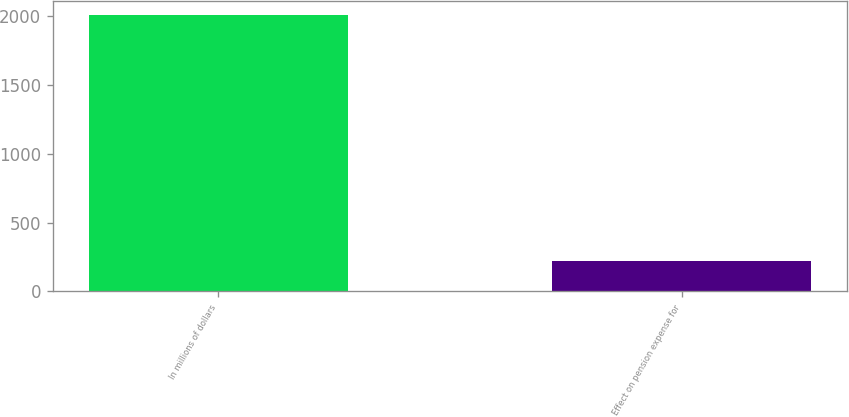Convert chart to OTSL. <chart><loc_0><loc_0><loc_500><loc_500><bar_chart><fcel>In millions of dollars<fcel>Effect on pension expense for<nl><fcel>2007<fcel>223.2<nl></chart> 